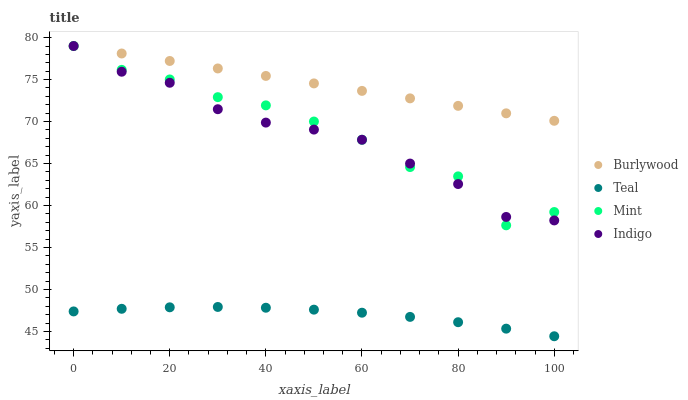Does Teal have the minimum area under the curve?
Answer yes or no. Yes. Does Burlywood have the maximum area under the curve?
Answer yes or no. Yes. Does Indigo have the minimum area under the curve?
Answer yes or no. No. Does Indigo have the maximum area under the curve?
Answer yes or no. No. Is Burlywood the smoothest?
Answer yes or no. Yes. Is Mint the roughest?
Answer yes or no. Yes. Is Indigo the smoothest?
Answer yes or no. No. Is Indigo the roughest?
Answer yes or no. No. Does Teal have the lowest value?
Answer yes or no. Yes. Does Indigo have the lowest value?
Answer yes or no. No. Does Mint have the highest value?
Answer yes or no. Yes. Does Teal have the highest value?
Answer yes or no. No. Is Teal less than Indigo?
Answer yes or no. Yes. Is Burlywood greater than Teal?
Answer yes or no. Yes. Does Burlywood intersect Indigo?
Answer yes or no. Yes. Is Burlywood less than Indigo?
Answer yes or no. No. Is Burlywood greater than Indigo?
Answer yes or no. No. Does Teal intersect Indigo?
Answer yes or no. No. 